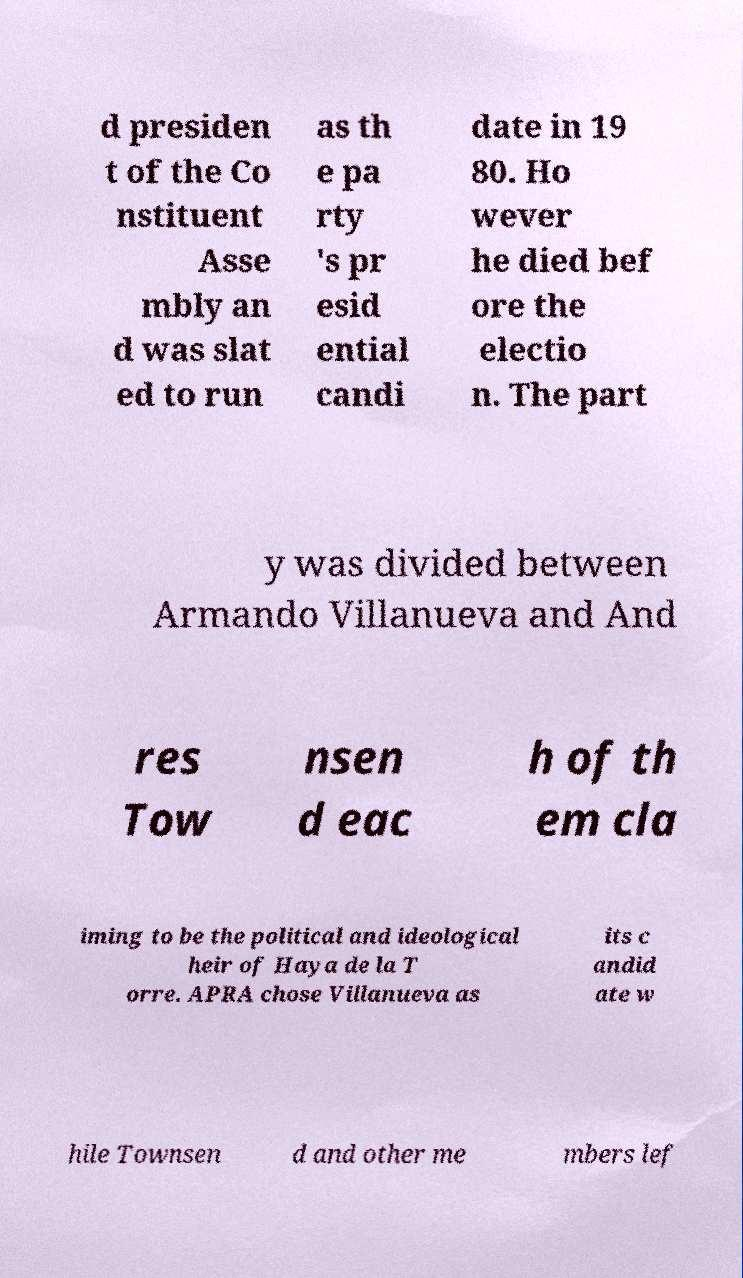Could you extract and type out the text from this image? d presiden t of the Co nstituent Asse mbly an d was slat ed to run as th e pa rty 's pr esid ential candi date in 19 80. Ho wever he died bef ore the electio n. The part y was divided between Armando Villanueva and And res Tow nsen d eac h of th em cla iming to be the political and ideological heir of Haya de la T orre. APRA chose Villanueva as its c andid ate w hile Townsen d and other me mbers lef 